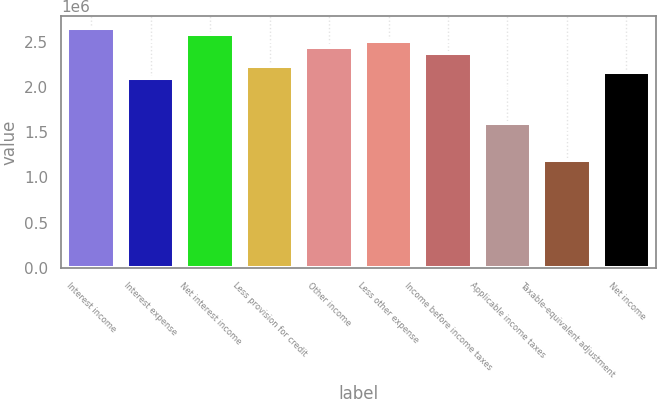<chart> <loc_0><loc_0><loc_500><loc_500><bar_chart><fcel>Interest income<fcel>Interest expense<fcel>Net interest income<fcel>Less provision for credit<fcel>Other income<fcel>Less other expense<fcel>Income before income taxes<fcel>Applicable income taxes<fcel>Taxable-equivalent adjustment<fcel>Net income<nl><fcel>2.65451e+06<fcel>2.09567e+06<fcel>2.58466e+06<fcel>2.23538e+06<fcel>2.44494e+06<fcel>2.5148e+06<fcel>2.37509e+06<fcel>1.60668e+06<fcel>1.18754e+06<fcel>2.16552e+06<nl></chart> 